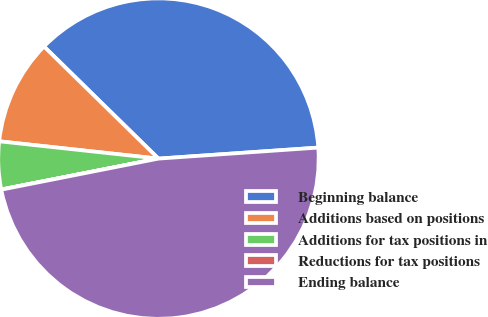Convert chart. <chart><loc_0><loc_0><loc_500><loc_500><pie_chart><fcel>Beginning balance<fcel>Additions based on positions<fcel>Additions for tax positions in<fcel>Reductions for tax positions<fcel>Ending balance<nl><fcel>36.57%<fcel>10.61%<fcel>4.81%<fcel>0.02%<fcel>47.99%<nl></chart> 